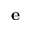Convert formula to latex. <formula><loc_0><loc_0><loc_500><loc_500>e</formula> 